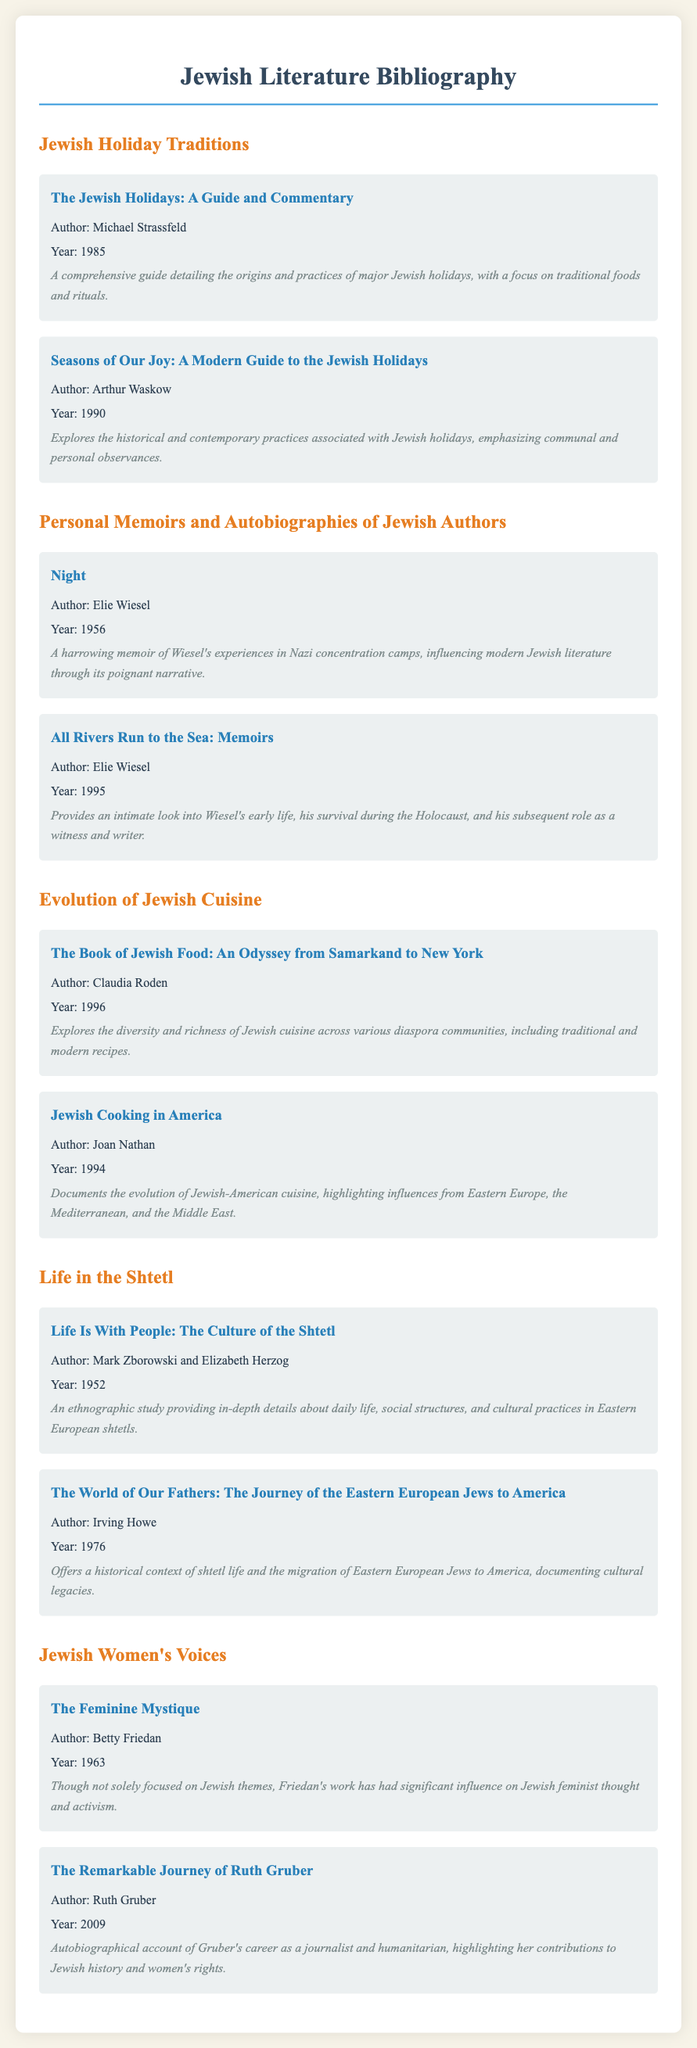what is the title of the book by Michael Strassfeld? The title of the book is listed under the Jewish Holiday Traditions section, authored by Michael Strassfeld.
Answer: The Jewish Holidays: A Guide and Commentary who authored the memoir titled "Night"? The author's name is provided right under the title in the Personal Memoirs section.
Answer: Elie Wiesel what year was "All Rivers Run to the Sea: Memoirs" published? The year of publication can be found next to the title of the book in the document.
Answer: 1995 name one book that discusses Jewish cuisine. This information can be found under the Evolution of Jewish Cuisine section, identifying books focused on that theme.
Answer: The Book of Jewish Food: An Odyssey from Samarkand to New York which author is associated with the book "The Feminine Mystique"? The author listed in the Jewish Women's Voices section indicates the origin of the work's authorship.
Answer: Betty Friedan how many books are listed under Life in the Shtetl? A count of books in that section is required based on the visible listings under that category.
Answer: 2 what focus does Ruth Gruber's book primarily address? This insight can be extrapolated from the description provided underneath the title in the Jewish Women's Voices section.
Answer: Women's rights what is the main theme of "Seasons of Our Joy"? The main theme can be deduced from the description that follows the title in the Jewish Holiday Traditions section.
Answer: Historical and contemporary practices 